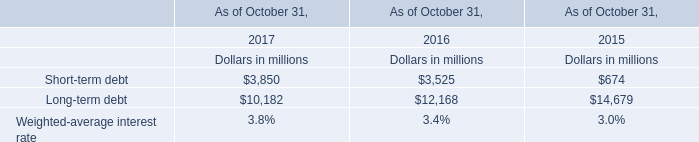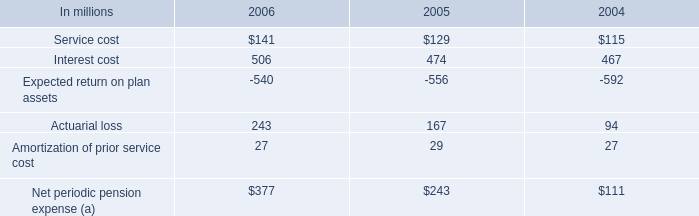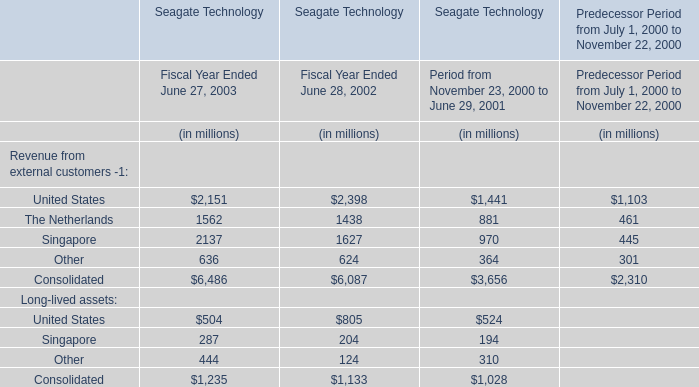What was the sum of Fiscal Year Ended June 27, 2003 without those elements smaller 1000? (in million) 
Computations: ((2151 + 1562) + 2137)
Answer: 5850.0. 